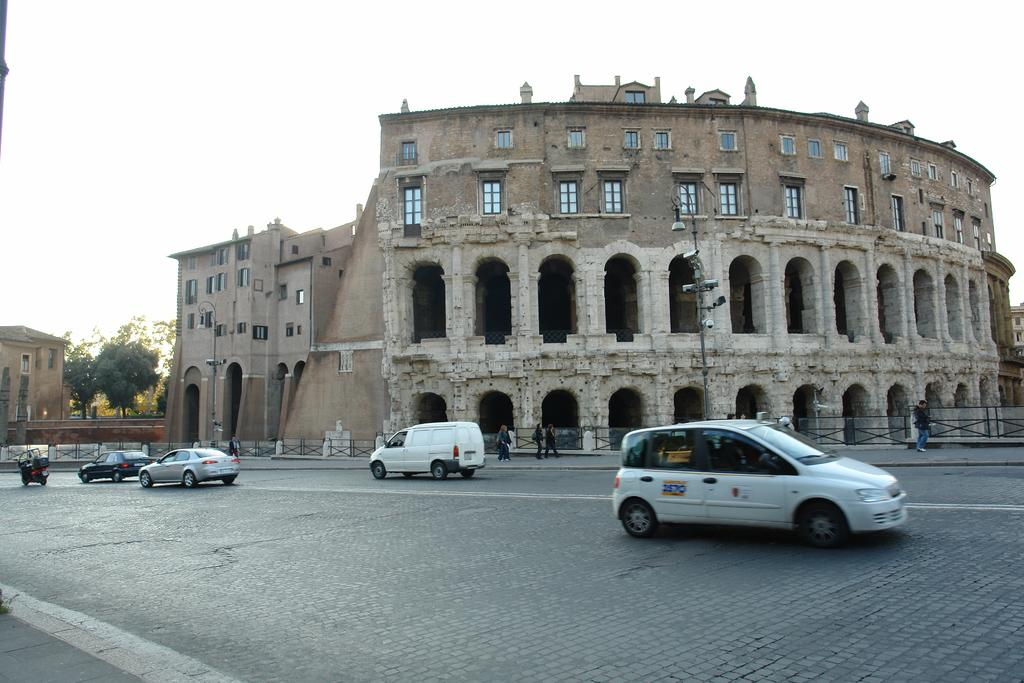What can be seen on the road in the image? There are vehicles on the road in the image. What is visible in the background of the image? There are buildings and trees in the background of the image. How many beetles can be seen crawling on the buildings in the image? There are no beetles visible in the image; it features vehicles on the road and buildings and trees in the background. What color is the tongue of the person in the image? There is no person present in the image, so it is not possible to determine the color of their tongue. 